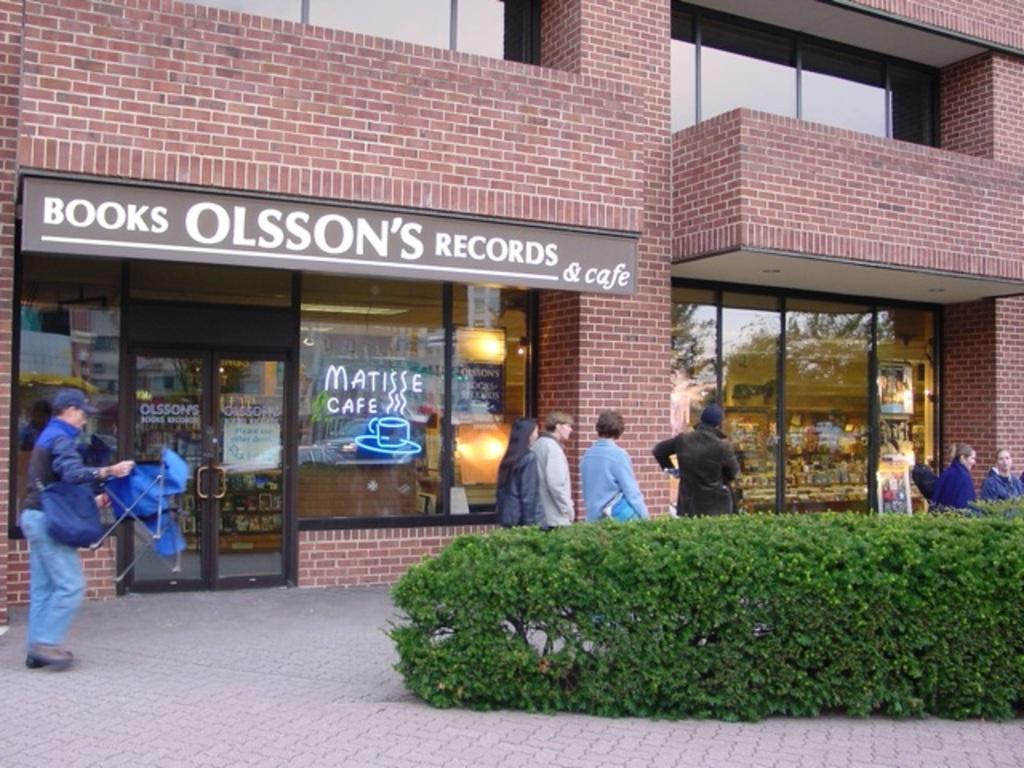How many people are in the image? There are people in the image, but the exact number is not specified. What is the man holding in his hands? A man is holding an object in his hands, but the specific object is not described. What type of vegetation is present in the image? There are plants in the image, but their exact type is not specified. What can be seen in the background of the image? There is a building, a glass wall, and a door in the background of the image. What type of quill is being used to play the instrument in the image? There is no quill or instrument present in the image. How many times does the man smash the glass wall in the image? There is no indication of anyone smashing the glass wall in the image. 